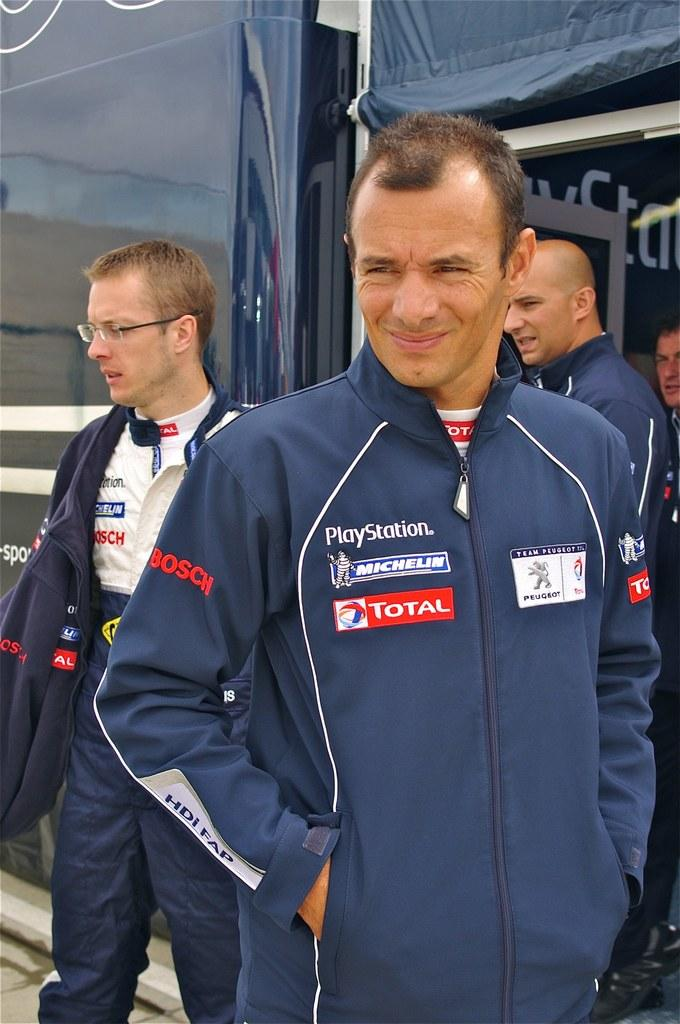<image>
Summarize the visual content of the image. Michelin logo, Playstation logo and Total logo on a blue jacket. 